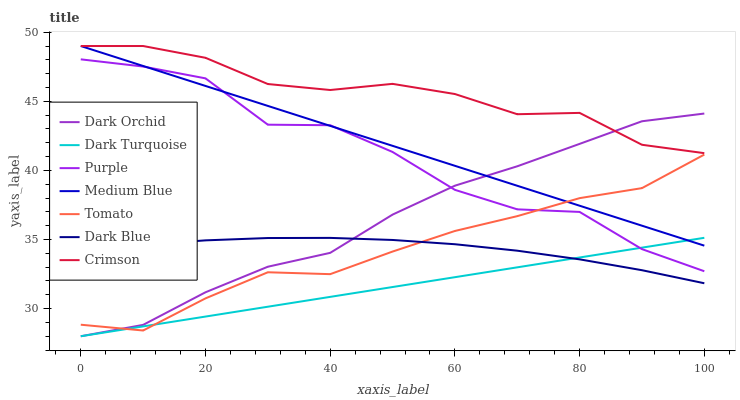Does Dark Turquoise have the minimum area under the curve?
Answer yes or no. Yes. Does Crimson have the maximum area under the curve?
Answer yes or no. Yes. Does Purple have the minimum area under the curve?
Answer yes or no. No. Does Purple have the maximum area under the curve?
Answer yes or no. No. Is Dark Turquoise the smoothest?
Answer yes or no. Yes. Is Purple the roughest?
Answer yes or no. Yes. Is Purple the smoothest?
Answer yes or no. No. Is Dark Turquoise the roughest?
Answer yes or no. No. Does Dark Turquoise have the lowest value?
Answer yes or no. Yes. Does Purple have the lowest value?
Answer yes or no. No. Does Crimson have the highest value?
Answer yes or no. Yes. Does Purple have the highest value?
Answer yes or no. No. Is Tomato less than Crimson?
Answer yes or no. Yes. Is Crimson greater than Purple?
Answer yes or no. Yes. Does Tomato intersect Dark Turquoise?
Answer yes or no. Yes. Is Tomato less than Dark Turquoise?
Answer yes or no. No. Is Tomato greater than Dark Turquoise?
Answer yes or no. No. Does Tomato intersect Crimson?
Answer yes or no. No. 